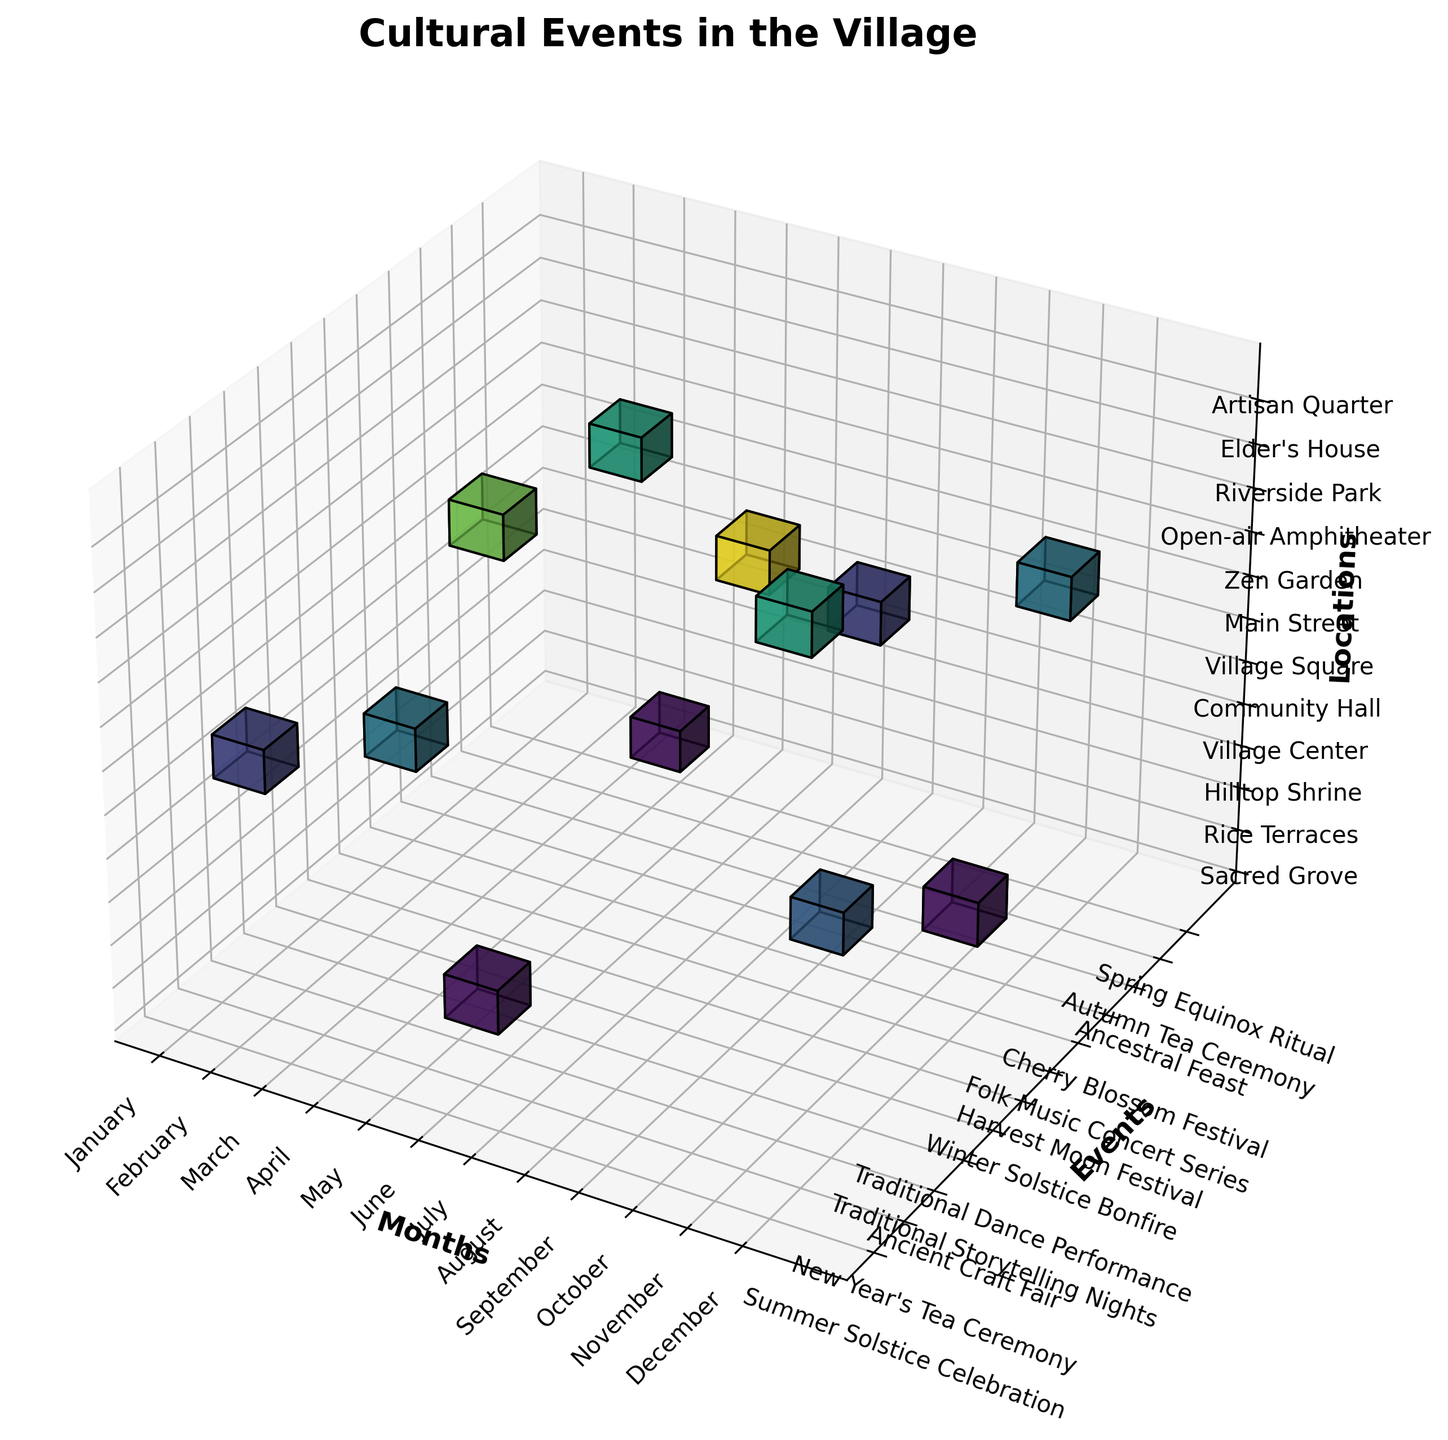When are the cultural events taking place in the village? The figure's title is "Cultural Events in the Village," and the x-axis representing months shows when the events occur, labeled from January to December.
Answer: January to December Which event has the highest frequency? Observing the color intensity along the scale, we see that the "Folk Music Concert Series" in July at the Open-air Amphitheater has the darkest shade, indicating the highest frequency value.
Answer: Folk Music Concert Series Which month has the most diverse event locations? Count the different events at each location for each month: July appears to have events in multiple venues (Open-air Amphitheater, Community Hall) compared to others.
Answer: July How does the frequency of the New Year's Tea Ceremony compare to the Winter Solstice Bonfire? Referencing the voxel colors for January (New Year's Tea Ceremony) and December (Winter Solstice Bonfire), the former has a brighter color indicating it is more frequent than the only 1 event in December.
Answer: New Year's Tea Ceremony is higher What combination of events and locations can only be seen once a year? Check for bright colors in voxel cells in the grid (indicating a frequency of 1), such as the Spring Equinox Ritual in Sacred Grove (March) and the Winter Solstice Bonfire in Village Center (December).
Answer: Several such as Spring Equinox Ritual in March Which season hosts the most cultural events? Count the number of events for each three-month seasonal block: Spring (March, April, May), Summer (June, July, August), Autumn (September, October, November), and Winter (December, January, February).
Answer: Summer Which location hosts the fewest number of events throughout the year? Look at events distribution across the z-axis; Sacred Grove and Hilltop Shrine barely register more than one event (Spring Equinox Ritual and Summer Solstice Celebration, respectively).
Answer: Sacred Grove and Hilltop Shrine Is there any correlation between months and event frequency? Sum up frequencies for events each month and observe trends: High summer months (May, June, July) reveal peak event counts compared to other months showing a summer inclination.
Answer: More in Summer months Are traditional storytelling nights more frequent than the Autumn Tea Ceremony? Compare colors of October (Traditional Storytelling Nights, darker in color = higher frequency) and November (Autumn Tea Ceremony, a bit lighter in color).
Answer: Yes, Traditional Storytelling Nights are more frequent Which event is more frequent, the Ancestral Feast or the Harvest Moon Festival? Check colors of the voxels for August (Ancestral Feast) and September (Harvest Moon Festival); Harvest Moon Festival appears with a darker, more frequent tone.
Answer: Harvest Moon Festival 